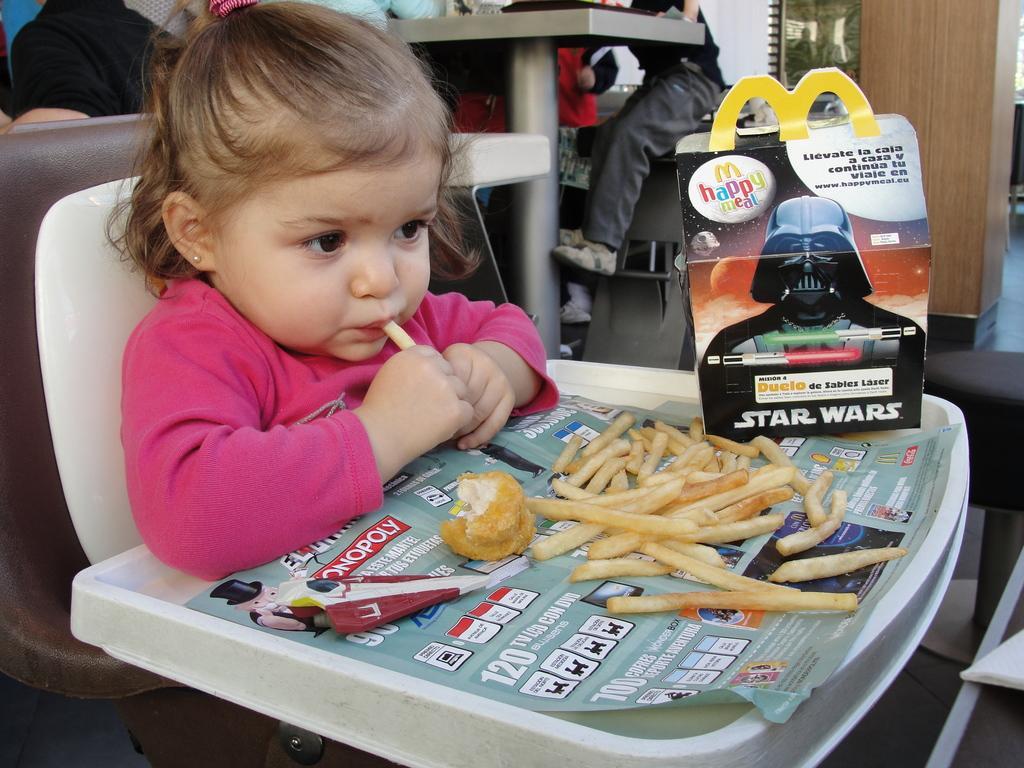Describe this image in one or two sentences. In this picture we can see a kid eating a food item and sitting on a baby chair with a table. We can see some food items and a few things on this table. We can see a few people and other objects. 